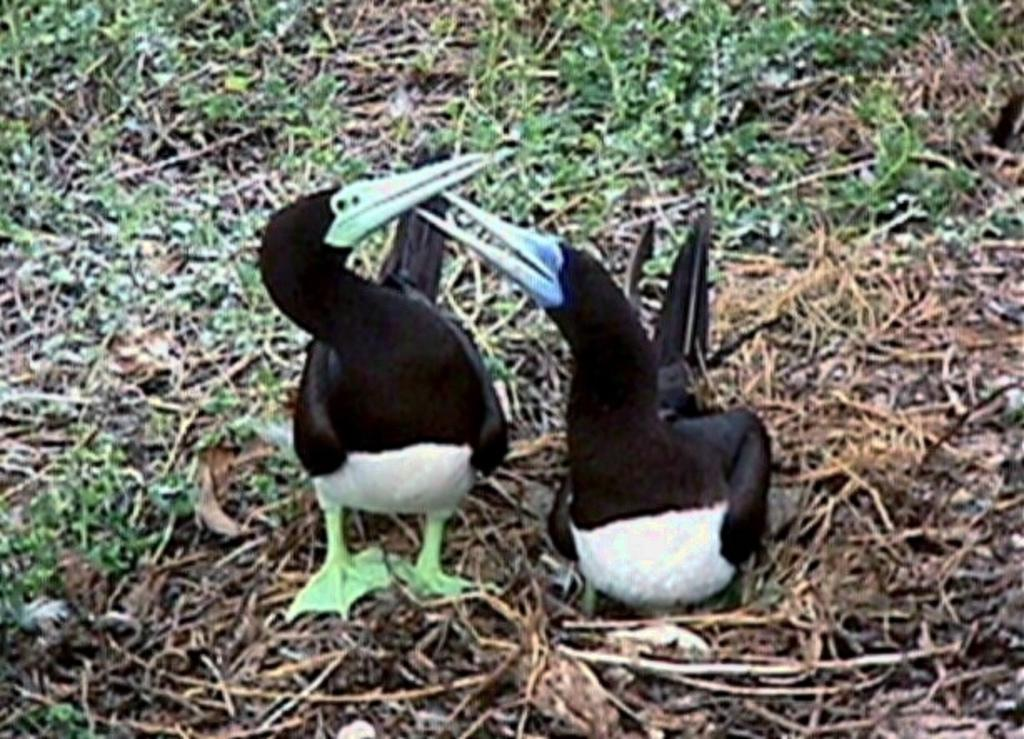What type of animals can be seen on the ground in the image? There are birds on the ground in the image. What type of vegetation is visible in the image? There is grass visible in the image. What type of board can be seen in the picture? There is no board present in the image; it features birds on the ground and grass. What type of rhythm can be heard in the image? There is no sound or rhythm present in the image, as it is a still photograph. 